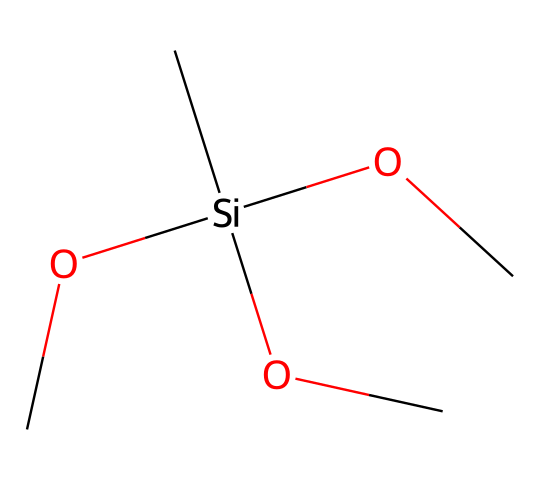What is the central atom in this silane? The central atom is silicon, which is evident from the structure. The notation "[Si]" indicates that silicon is the main framework of the molecule.
Answer: silicon How many oxygen atoms are present in this silane? Count the "O" symbols in the structure. There are three "O" representations, indicating that there are three oxygen atoms present.
Answer: three What is the total number of carbon atoms in this molecule? Count the "C" symbols in the structure. The structure shows a total of four "C" representations, signifying four carbon atoms are present.
Answer: four What type of compound is represented by this structure? The presence of silicon and carbon bonded to oxygen suggests that this is a silane compound, specifically a trialkoxysilane.
Answer: silane What functional groups can be identified from this silane? The molecule contains alkoxy groups (-O-alkyl), specifically indicated by the "OC" parts that are bonded to silicon. These represent the presence of functional groups that modify properties like solubility and bonding with surfaces.
Answer: alkoxy groups How can this silane contribute to waterproofing historical artifacts? The alkoxy groups facilitate binding to surfaces while the silicon center provides hydrophobic characteristics, creating a protective barrier against moisture, essential for preserving artifacts.
Answer: hydrophobic barrier What property does the silicon atom impart to the overall structure? The silicon atom provides structural stability and hydrophobic properties, enhancing the compound's ability to repel water and protect treated surfaces from moisture.
Answer: stability and hydrophobicity 